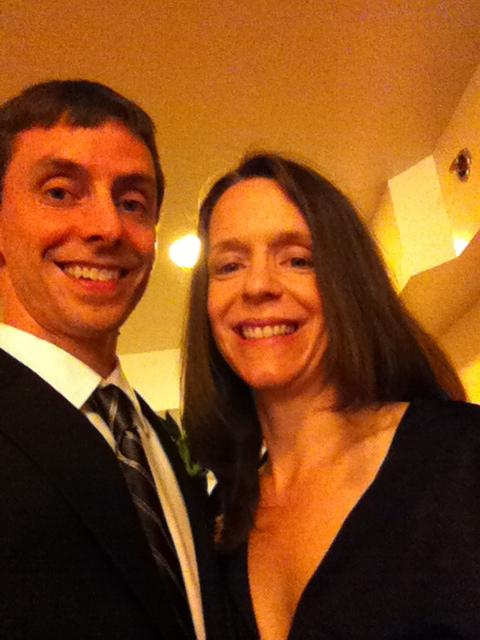Is the woman happy?
Answer briefly. Yes. Are the people smiling?
Short answer required. Yes. Is the guy wearing a tie or bow tie?
Answer briefly. Tie. 